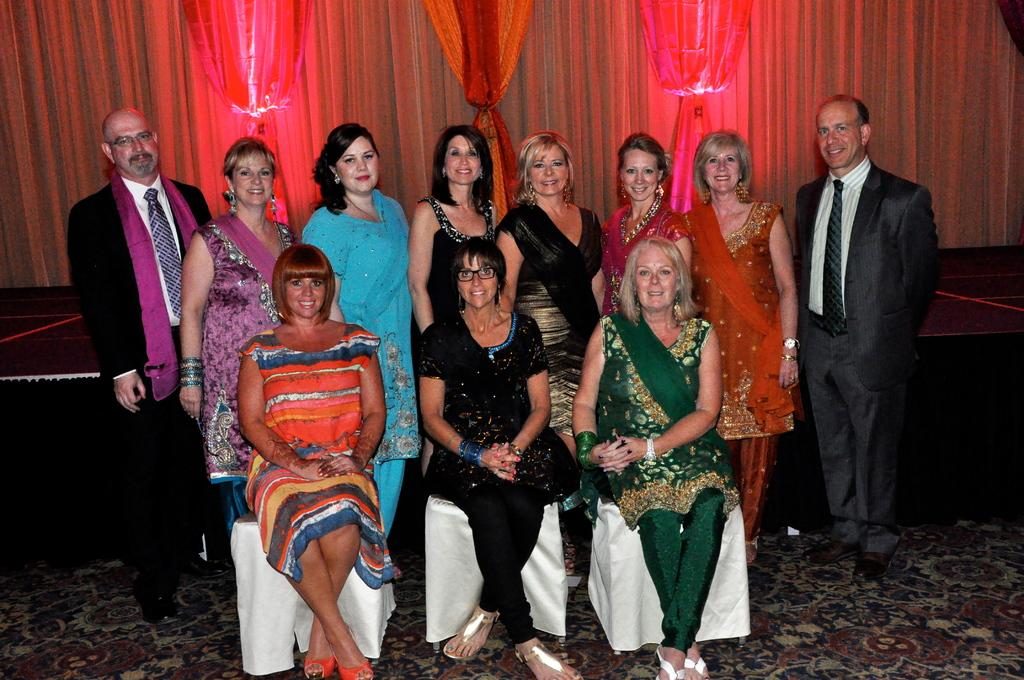How many people are in the image? There is a group of persons in the image. What are the people in the image doing? The persons are sitting and standing, and they are smiling. What can be seen in the background of the image? There are red curtains in the background of the image. What type of bag can be seen hanging from the peace cart in the image? There is no bag, peace cart, or any related objects present in the image. 